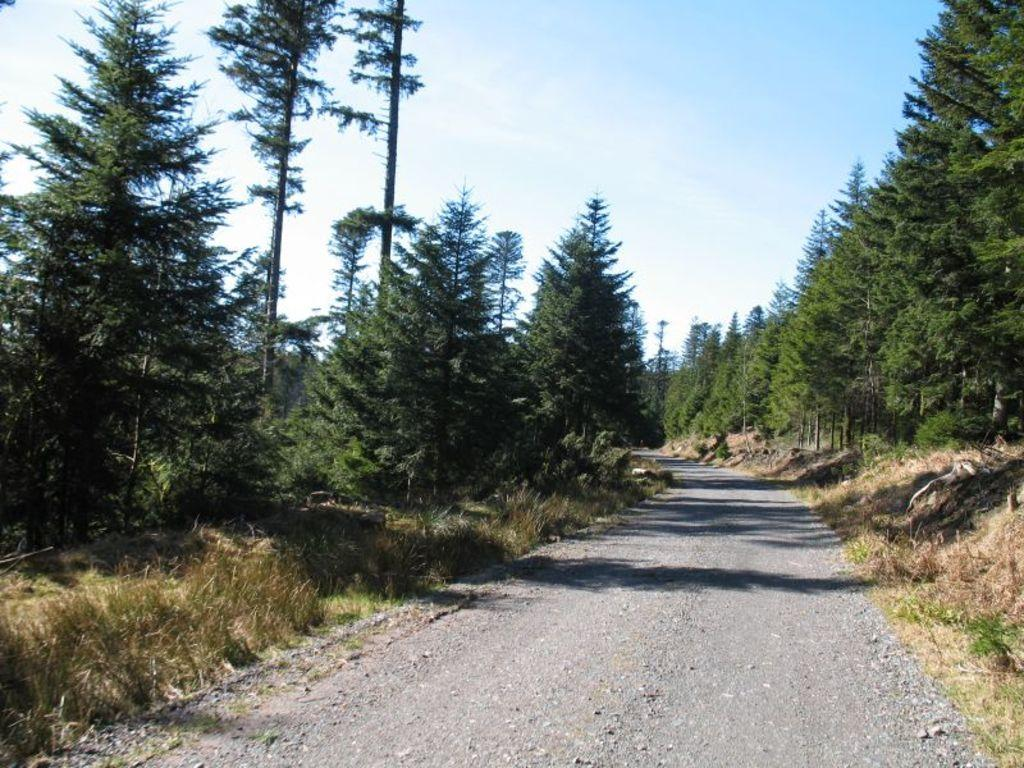What is the main feature of the landscape in the image? There is a road in the image. What type of vegetation can be seen in the image? There are trees in the image. What is the ground cover in the image? There is grass visible in the image. What is visible in the background of the image? The sky is visible in the image. Can you tell me how fast the robin is flying in the image? There is no robin present in the image, so it is not possible to determine its flying speed. What type of furniture is visible in the image? There is no furniture visible in the image. 